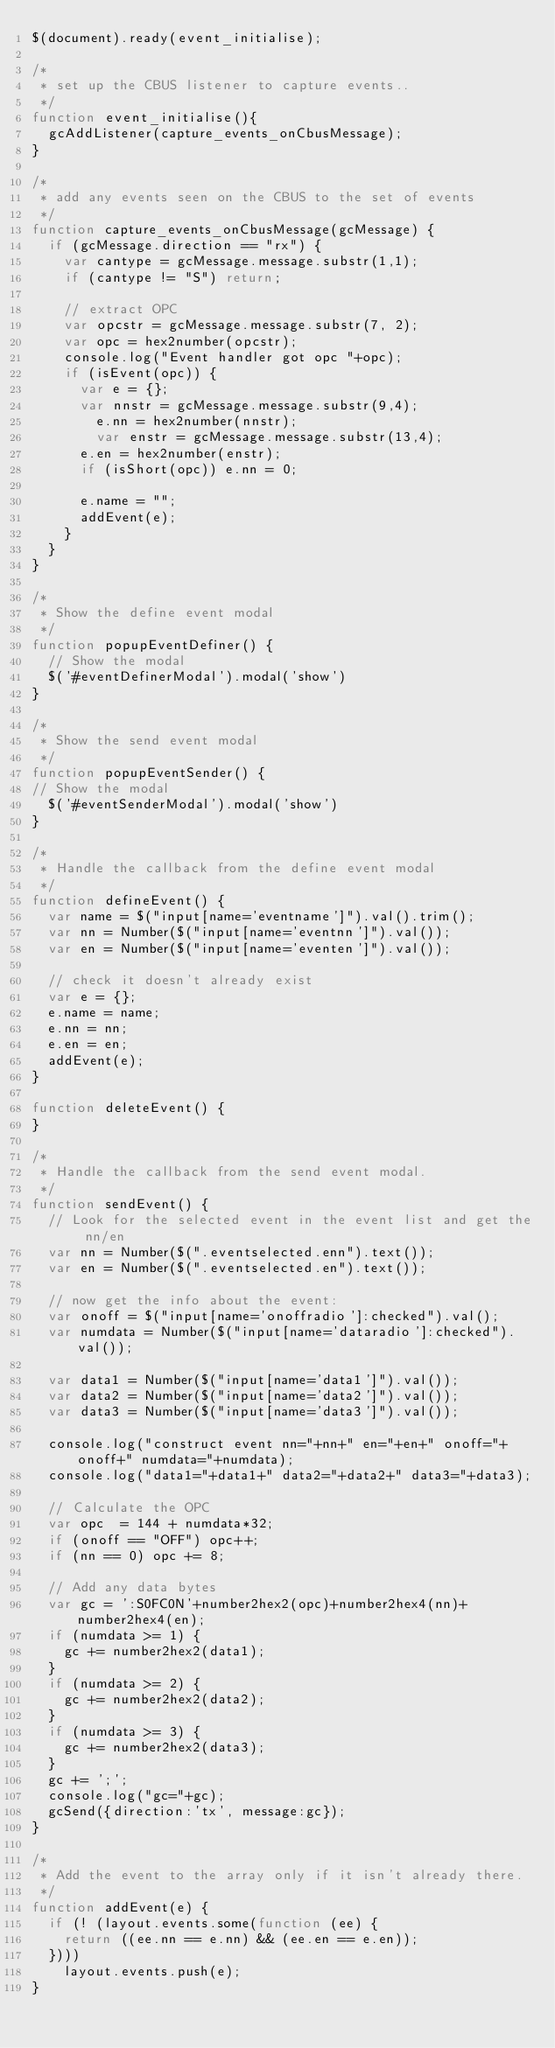Convert code to text. <code><loc_0><loc_0><loc_500><loc_500><_JavaScript_>$(document).ready(event_initialise);

/*
 * set up the CBUS listener to capture events..
 */
function event_initialise(){
	gcAddListener(capture_events_onCbusMessage);
}

/*
 * add any events seen on the CBUS to the set of events
 */
function capture_events_onCbusMessage(gcMessage) {
	if (gcMessage.direction == "rx") {
		var cantype = gcMessage.message.substr(1,1);
		if (cantype != "S") return;
		
		// extract OPC
		var opcstr = gcMessage.message.substr(7, 2);
		var opc = hex2number(opcstr);
		console.log("Event handler got opc "+opc);
		if (isEvent(opc)) {
			var e = {};
			var nnstr = gcMessage.message.substr(9,4);
    		e.nn = hex2number(nnstr);
    		var enstr = gcMessage.message.substr(13,4);
			e.en = hex2number(enstr);
			if (isShort(opc)) e.nn = 0;

			e.name = "";
			addEvent(e);
		} 
	}
}

/*
 * Show the define event modal
 */
function popupEventDefiner() {
	// Show the modal
	$('#eventDefinerModal').modal('show')
}

/*
 * Show the send event modal
 */
function popupEventSender() {
// Show the modal
	$('#eventSenderModal').modal('show')
}

/*
 * Handle the callback from the define event modal
 */
function defineEvent() {
	var name = $("input[name='eventname']").val().trim();
	var nn = Number($("input[name='eventnn']").val());
	var en = Number($("input[name='eventen']").val());

	// check it doesn't already exist
	var e = {};
	e.name = name;
	e.nn = nn;
	e.en = en;
	addEvent(e);
}

function deleteEvent() {
}

/*
 * Handle the callback from the send event modal.
 */
function sendEvent() {
	// Look for the selected event in the event list and get the nn/en
	var nn = Number($(".eventselected.enn").text());
	var en = Number($(".eventselected.en").text());
	
	// now get the info about the event:
	var onoff = $("input[name='onoffradio']:checked").val();
	var numdata = Number($("input[name='dataradio']:checked").val());
	
	var data1 = Number($("input[name='data1']").val());
	var data2 = Number($("input[name='data2']").val());
	var data3 = Number($("input[name='data3']").val());
	
	console.log("construct event nn="+nn+" en="+en+" onoff="+onoff+" numdata="+numdata);
	console.log("data1="+data1+" data2="+data2+" data3="+data3);
	
	// Calculate the OPC
	var opc  = 144 + numdata*32;
	if (onoff == "OFF") opc++;
	if (nn == 0) opc += 8;
	
	// Add any data bytes
	var gc = ':S0FC0N'+number2hex2(opc)+number2hex4(nn)+number2hex4(en);
	if (numdata >= 1) {
		gc += number2hex2(data1);
	}
	if (numdata >= 2) {
		gc += number2hex2(data2);
	}
	if (numdata >= 3) {
		gc += number2hex2(data3);
	}
	gc += ';';
	console.log("gc="+gc);
	gcSend({direction:'tx', message:gc});
}

/*
 * Add the event to the array only if it isn't already there.
 */
function addEvent(e) {
	if (! (layout.events.some(function (ee) {
		return ((ee.nn == e.nn) && (ee.en == e.en));
	})))
		layout.events.push(e);
}</code> 